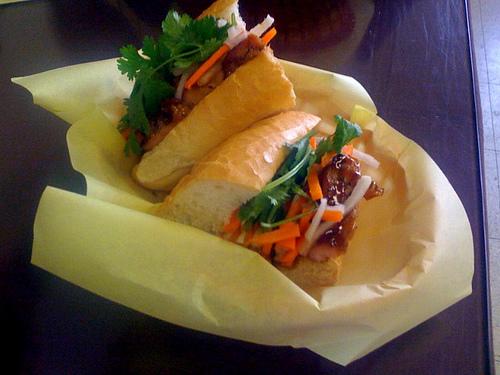Should this be eaten with a fork?
Keep it brief. No. Is this meal healthy?
Keep it brief. Yes. What kind of sandwich is this?
Short answer required. Sub sandwich. What kind of restaurant is this?
Keep it brief. American. Is this food from a restaurant?
Keep it brief. Yes. 